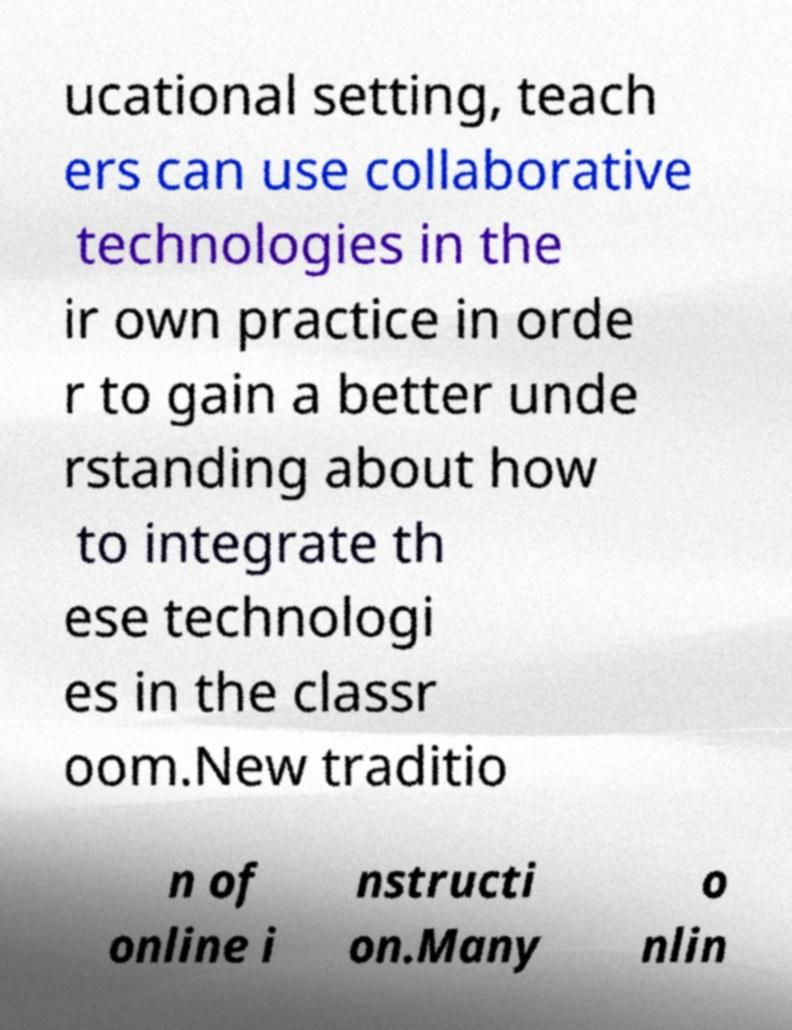For documentation purposes, I need the text within this image transcribed. Could you provide that? ucational setting, teach ers can use collaborative technologies in the ir own practice in orde r to gain a better unde rstanding about how to integrate th ese technologi es in the classr oom.New traditio n of online i nstructi on.Many o nlin 